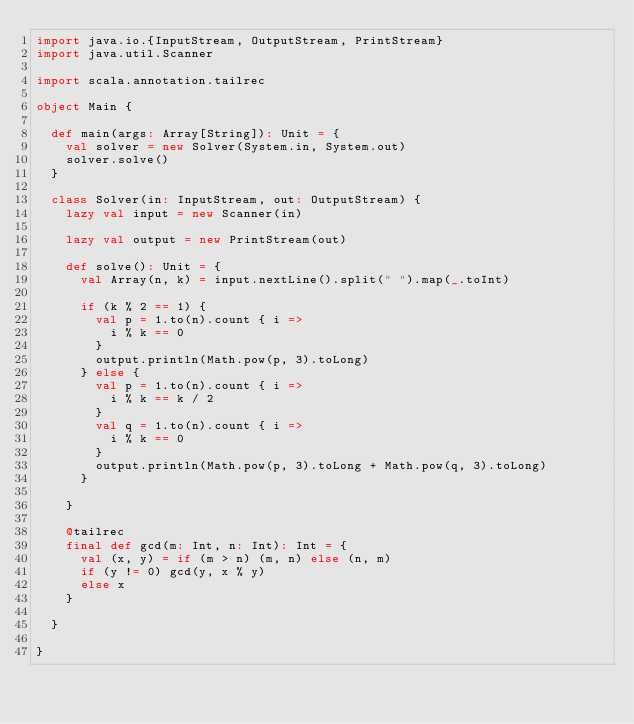Convert code to text. <code><loc_0><loc_0><loc_500><loc_500><_Scala_>import java.io.{InputStream, OutputStream, PrintStream}
import java.util.Scanner

import scala.annotation.tailrec

object Main {

  def main(args: Array[String]): Unit = {
    val solver = new Solver(System.in, System.out)
    solver.solve()
  }

  class Solver(in: InputStream, out: OutputStream) {
    lazy val input = new Scanner(in)

    lazy val output = new PrintStream(out)

    def solve(): Unit = {
      val Array(n, k) = input.nextLine().split(" ").map(_.toInt)

      if (k % 2 == 1) {
        val p = 1.to(n).count { i =>
          i % k == 0
        }
        output.println(Math.pow(p, 3).toLong)
      } else {
        val p = 1.to(n).count { i =>
          i % k == k / 2
        }
        val q = 1.to(n).count { i =>
          i % k == 0
        }
        output.println(Math.pow(p, 3).toLong + Math.pow(q, 3).toLong)
      }

    }

    @tailrec
    final def gcd(m: Int, n: Int): Int = {
      val (x, y) = if (m > n) (m, n) else (n, m)
      if (y != 0) gcd(y, x % y)
      else x
    }

  }

}
</code> 